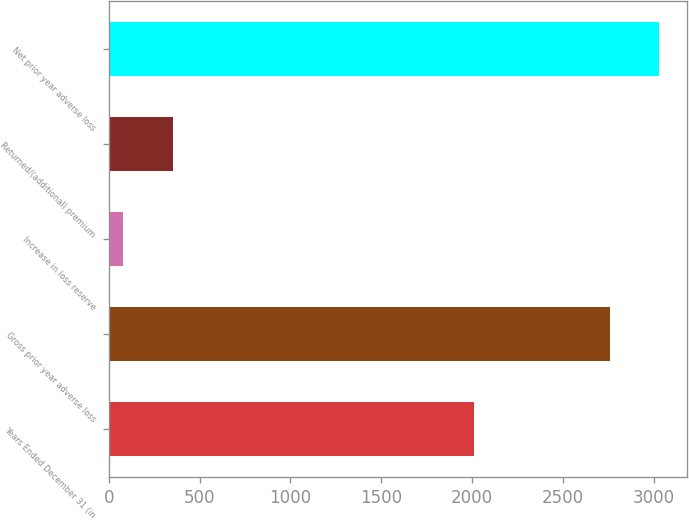Convert chart. <chart><loc_0><loc_0><loc_500><loc_500><bar_chart><fcel>Years Ended December 31 (in<fcel>Gross prior year adverse loss<fcel>Increase in loss reserve<fcel>Returned/(additional) premium<fcel>Net prior year adverse loss<nl><fcel>2009<fcel>2758<fcel>81<fcel>352.4<fcel>3029.4<nl></chart> 